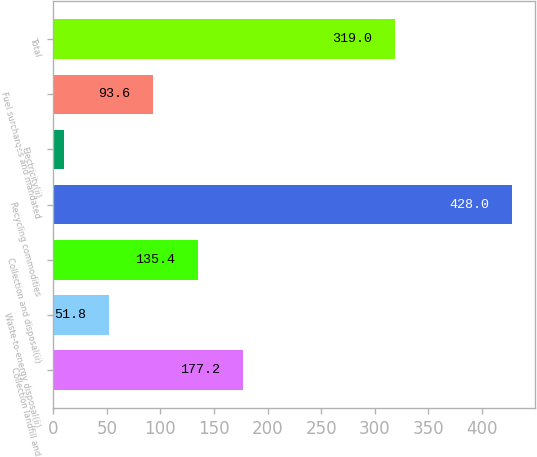Convert chart. <chart><loc_0><loc_0><loc_500><loc_500><bar_chart><fcel>Collection landfill and<fcel>Waste-to-energy disposal(ii)<fcel>Collection and disposal(ii)<fcel>Recycling commodities<fcel>Electricity(ii)<fcel>Fuel surcharges and mandated<fcel>Total<nl><fcel>177.2<fcel>51.8<fcel>135.4<fcel>428<fcel>10<fcel>93.6<fcel>319<nl></chart> 